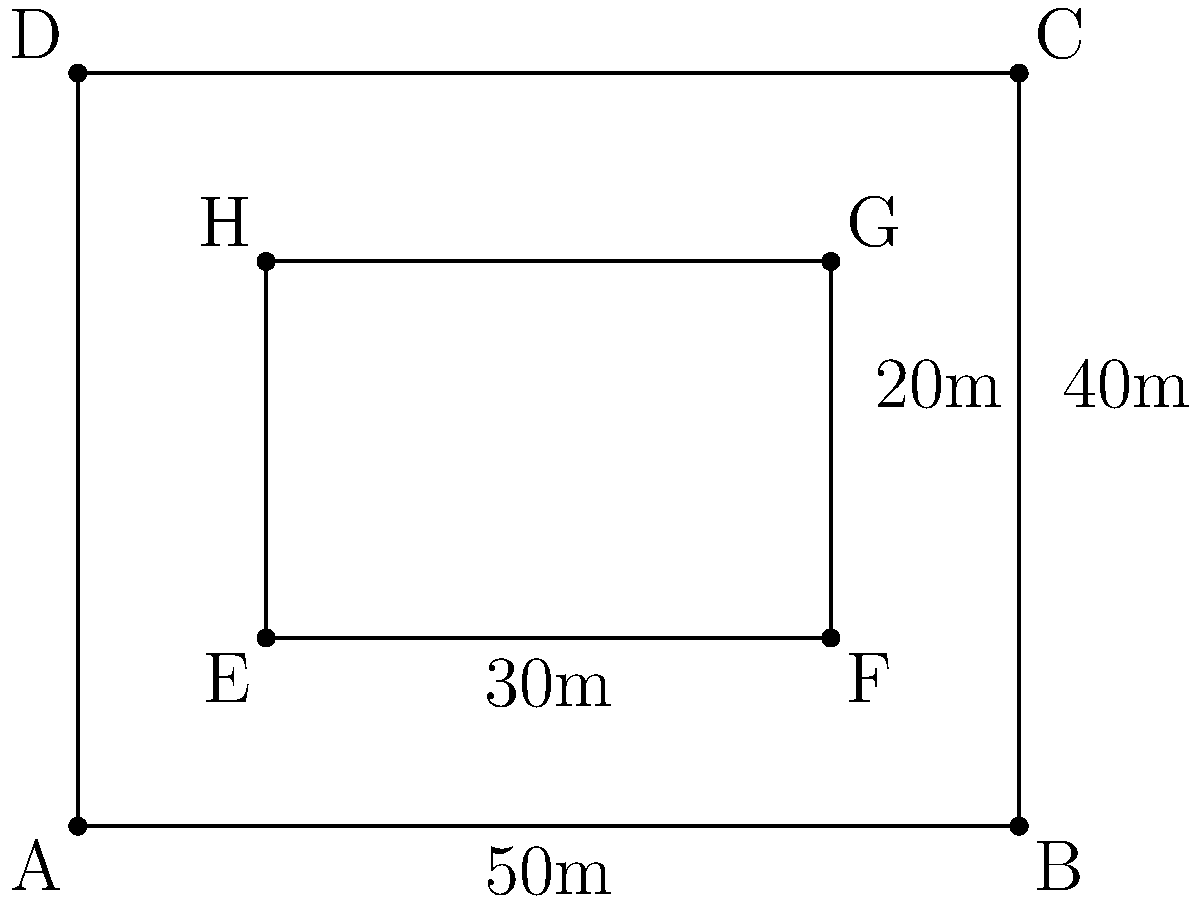Your horse requires 1 acre of pasture for grazing. The diagram shows a rectangular field ABCD with dimensions 50m by 40m. Inside this field is a smaller rectangular area EFGH that cannot be used for grazing due to a pond. If the inner rectangle measures 30m by 20m, determine if this field provides sufficient grazing area for your horse. (Note: 1 acre ≈ 4046.86 m²) To solve this problem, we'll follow these steps:

1) Calculate the total area of the field (ABCD):
   Area of ABCD = $50\text{ m} \times 40\text{ m} = 2000\text{ m}^2$

2) Calculate the area of the pond (EFGH):
   Area of EFGH = $30\text{ m} \times 20\text{ m} = 600\text{ m}^2$

3) Calculate the available grazing area:
   Grazing area = Total area - Pond area
                = $2000\text{ m}^2 - 600\text{ m}^2 = 1400\text{ m}^2$

4) Convert 1 acre to square meters:
   1 acre ≈ 4046.86 m²

5) Compare the available grazing area to the required area:
   Required area: 4046.86 m²
   Available area: 1400 m²

6) Determine if the available area is sufficient:
   1400 m² < 4046.86 m²

Therefore, the available grazing area (1400 m²) is less than the required 1 acre (4046.86 m²) for the horse.
Answer: No, insufficient grazing area 